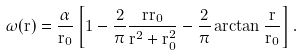<formula> <loc_0><loc_0><loc_500><loc_500>\omega ( r ) = \frac { \alpha } { r _ { 0 } } \left [ 1 - \frac { 2 } { \pi } \frac { r r _ { 0 } } { r ^ { 2 } + r _ { 0 } ^ { 2 } } - \frac { 2 } { \pi } \arctan \frac { r } { r _ { 0 } } \right ] .</formula> 